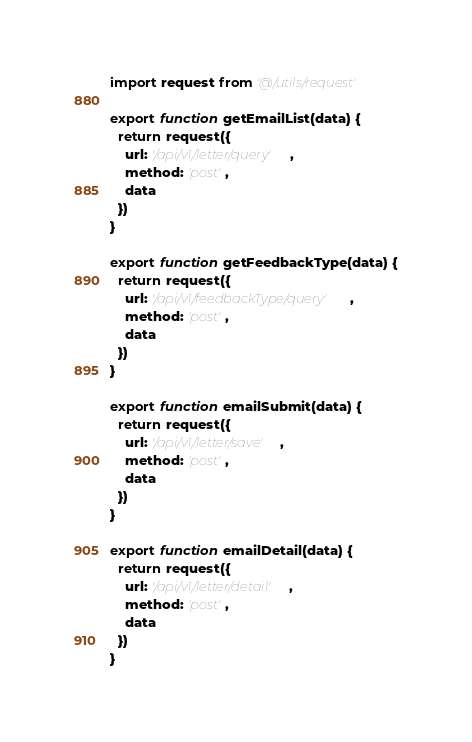Convert code to text. <code><loc_0><loc_0><loc_500><loc_500><_JavaScript_>import request from '@/utils/request'

export function getEmailList(data) {
  return request({
    url: '/api/v1/letter/query',
    method: 'post',
    data
  })
}

export function getFeedbackType(data) {
  return request({
    url: '/api/v1/feedbackType/query',
    method: 'post',
    data
  })
}

export function emailSubmit(data) {
  return request({
    url: '/api/v1/letter/save',
    method: 'post',
    data
  })
}

export function emailDetail(data) {
  return request({
    url: '/api/v1/letter/detail',
    method: 'post',
    data
  })
}</code> 